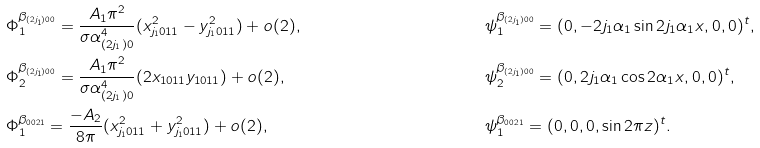Convert formula to latex. <formula><loc_0><loc_0><loc_500><loc_500>& \Phi _ { 1 } ^ { \beta _ { ( 2 j _ { 1 } ) 0 0 } } = \frac { A _ { 1 } \pi ^ { 2 } } { \sigma \alpha _ { ( 2 j _ { 1 } ) 0 } ^ { 4 } } ( x _ { j _ { 1 } 0 1 1 } ^ { 2 } - y _ { j _ { 1 } 0 1 1 } ^ { 2 } ) + o ( 2 ) , & & \psi _ { 1 } ^ { \beta _ { ( 2 j _ { 1 } ) 0 0 } } = ( 0 , - 2 j _ { 1 } \alpha _ { 1 } \sin 2 j _ { 1 } \alpha _ { 1 } x , 0 , 0 ) ^ { t } , \\ & \Phi _ { 2 } ^ { \beta _ { ( 2 j _ { 1 } ) 0 0 } } = \frac { A _ { 1 } \pi ^ { 2 } } { \sigma \alpha _ { ( 2 j _ { 1 } ) 0 } ^ { 4 } } ( 2 x _ { 1 0 1 1 } y _ { 1 0 1 1 } ) + o ( 2 ) , & & \psi _ { 2 } ^ { \beta _ { ( 2 j _ { 1 } ) 0 0 } } = ( 0 , 2 j _ { 1 } \alpha _ { 1 } \cos 2 \alpha _ { 1 } x , 0 , 0 ) ^ { t } , \\ & \Phi _ { 1 } ^ { \beta _ { 0 0 2 1 } } = \frac { - A _ { 2 } } { 8 \pi } ( x _ { j _ { 1 } 0 1 1 } ^ { 2 } + y _ { j _ { 1 } 0 1 1 } ^ { 2 } ) + o ( 2 ) , & & \psi _ { 1 } ^ { \beta _ { 0 0 2 1 } } = ( 0 , 0 , 0 , \sin 2 \pi z ) ^ { t } .</formula> 